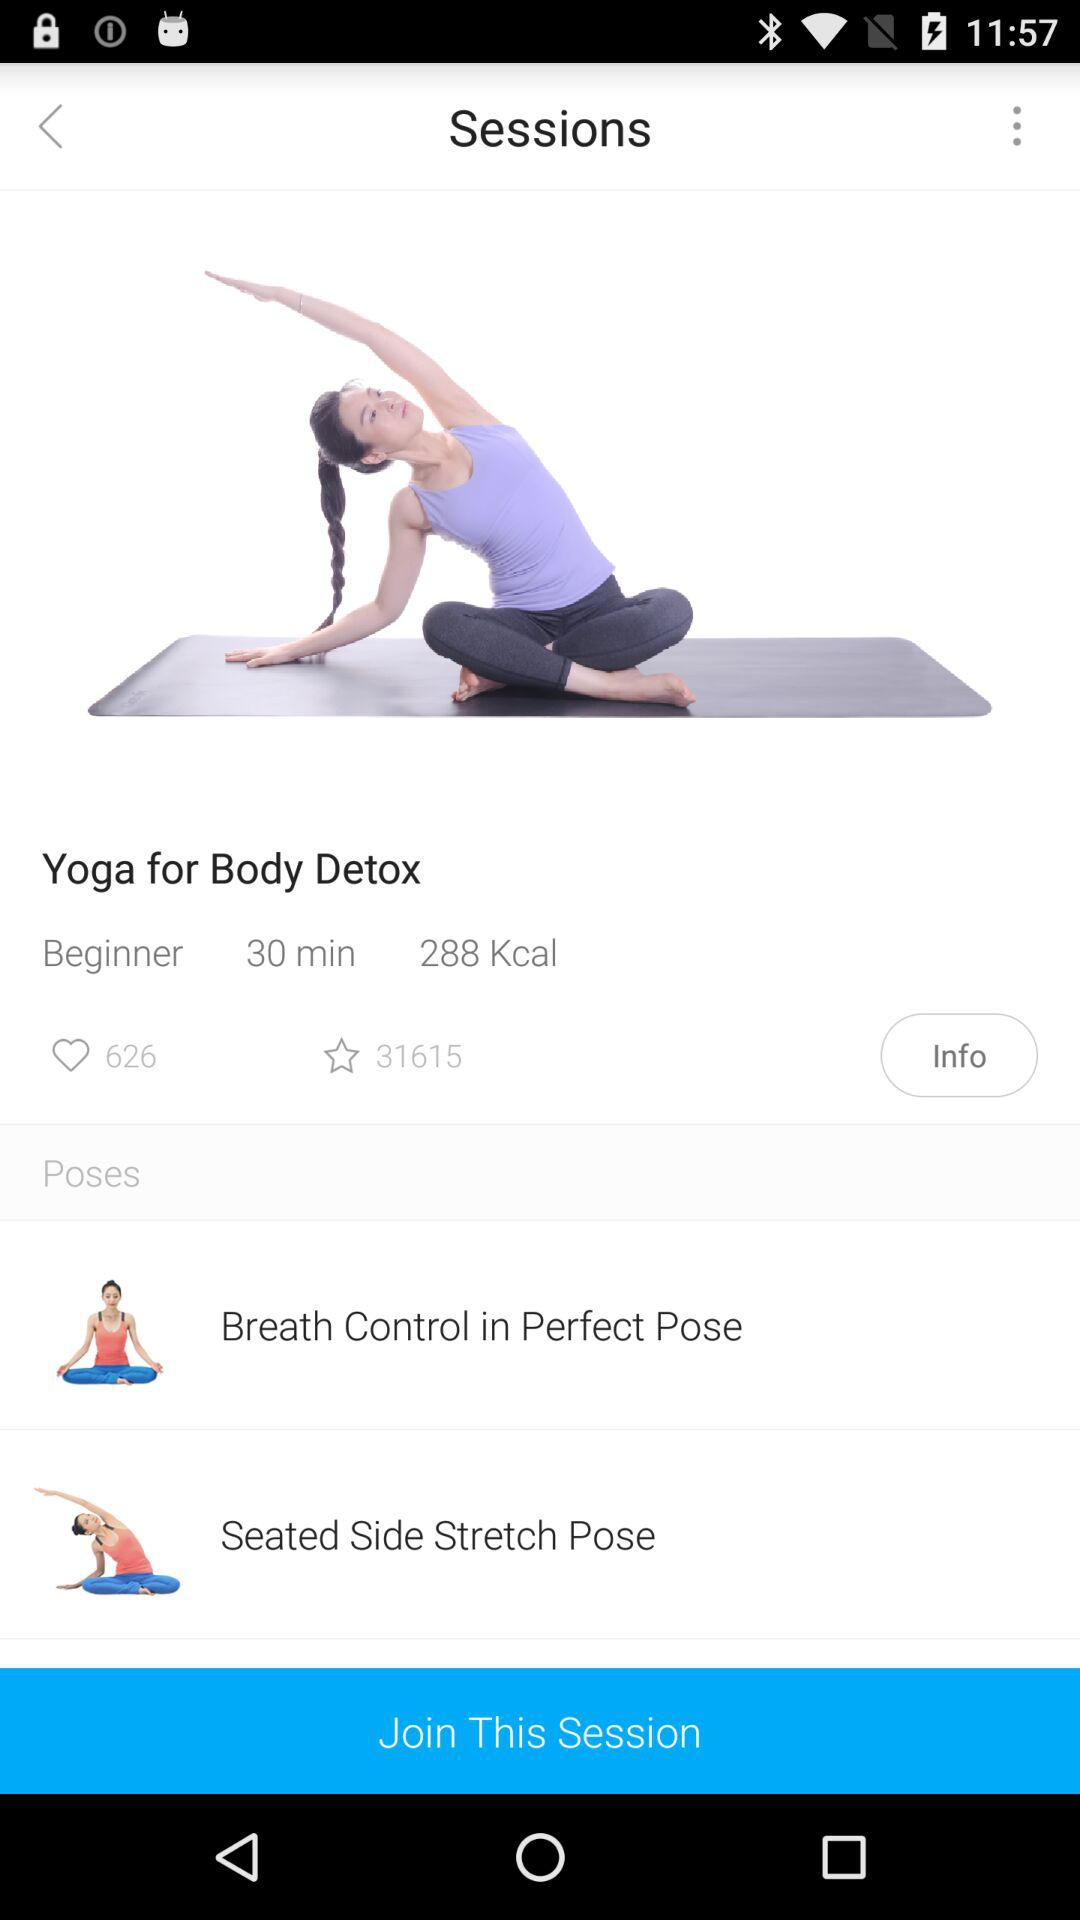What is the number of kilocalories? The number of kilocalories is 288. 